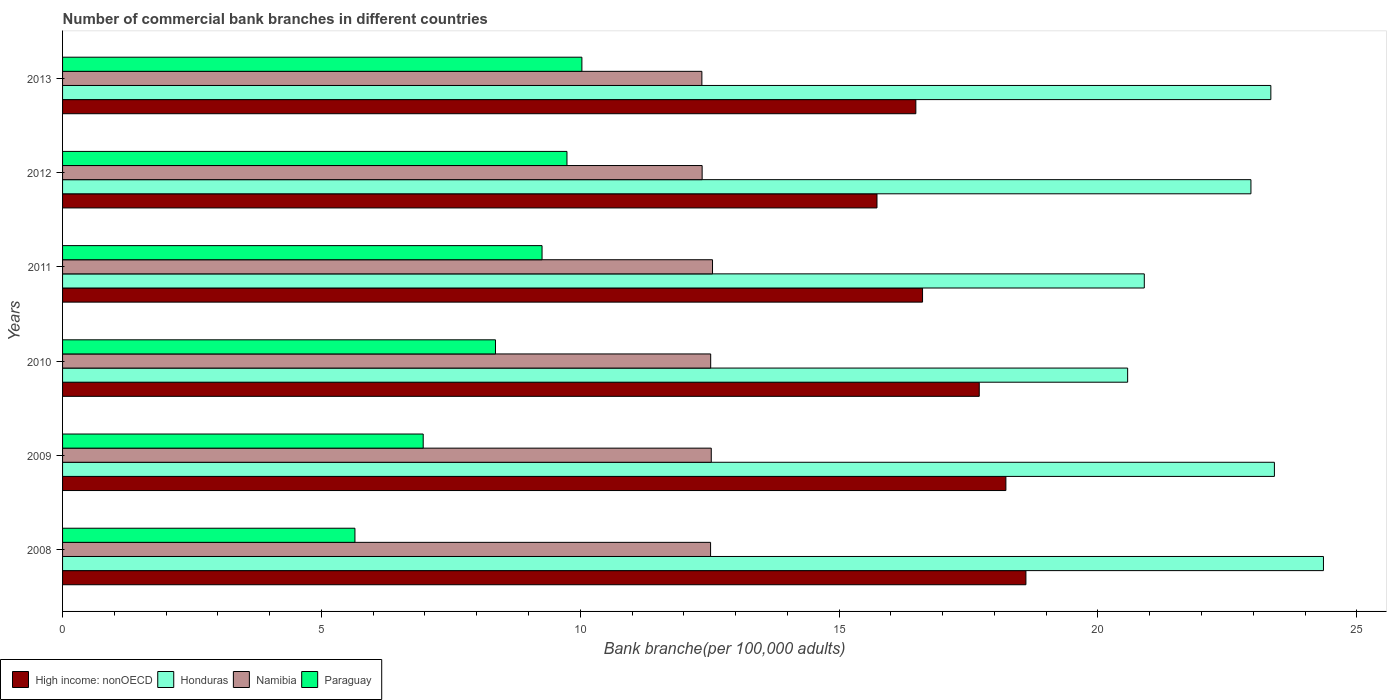Are the number of bars per tick equal to the number of legend labels?
Keep it short and to the point. Yes. How many bars are there on the 3rd tick from the bottom?
Your answer should be compact. 4. What is the label of the 5th group of bars from the top?
Keep it short and to the point. 2009. In how many cases, is the number of bars for a given year not equal to the number of legend labels?
Your answer should be compact. 0. What is the number of commercial bank branches in Namibia in 2013?
Ensure brevity in your answer.  12.35. Across all years, what is the maximum number of commercial bank branches in Namibia?
Keep it short and to the point. 12.55. Across all years, what is the minimum number of commercial bank branches in High income: nonOECD?
Provide a succinct answer. 15.73. In which year was the number of commercial bank branches in Honduras maximum?
Offer a terse response. 2008. What is the total number of commercial bank branches in Honduras in the graph?
Your response must be concise. 135.52. What is the difference between the number of commercial bank branches in High income: nonOECD in 2008 and that in 2011?
Offer a very short reply. 2. What is the difference between the number of commercial bank branches in Honduras in 2009 and the number of commercial bank branches in High income: nonOECD in 2012?
Ensure brevity in your answer.  7.68. What is the average number of commercial bank branches in High income: nonOECD per year?
Give a very brief answer. 17.23. In the year 2013, what is the difference between the number of commercial bank branches in Honduras and number of commercial bank branches in High income: nonOECD?
Offer a terse response. 6.86. In how many years, is the number of commercial bank branches in Namibia greater than 4 ?
Offer a terse response. 6. What is the ratio of the number of commercial bank branches in Paraguay in 2010 to that in 2011?
Provide a short and direct response. 0.9. What is the difference between the highest and the second highest number of commercial bank branches in High income: nonOECD?
Ensure brevity in your answer.  0.39. What is the difference between the highest and the lowest number of commercial bank branches in Honduras?
Ensure brevity in your answer.  3.78. In how many years, is the number of commercial bank branches in Honduras greater than the average number of commercial bank branches in Honduras taken over all years?
Provide a short and direct response. 4. What does the 2nd bar from the top in 2011 represents?
Give a very brief answer. Namibia. What does the 3rd bar from the bottom in 2011 represents?
Ensure brevity in your answer.  Namibia. How many bars are there?
Make the answer very short. 24. How many years are there in the graph?
Give a very brief answer. 6. What is the difference between two consecutive major ticks on the X-axis?
Provide a short and direct response. 5. Does the graph contain any zero values?
Offer a very short reply. No. What is the title of the graph?
Offer a terse response. Number of commercial bank branches in different countries. What is the label or title of the X-axis?
Keep it short and to the point. Bank branche(per 100,0 adults). What is the label or title of the Y-axis?
Give a very brief answer. Years. What is the Bank branche(per 100,000 adults) of High income: nonOECD in 2008?
Your answer should be compact. 18.61. What is the Bank branche(per 100,000 adults) in Honduras in 2008?
Provide a short and direct response. 24.36. What is the Bank branche(per 100,000 adults) of Namibia in 2008?
Your answer should be compact. 12.52. What is the Bank branche(per 100,000 adults) of Paraguay in 2008?
Your answer should be very brief. 5.65. What is the Bank branche(per 100,000 adults) in High income: nonOECD in 2009?
Offer a terse response. 18.22. What is the Bank branche(per 100,000 adults) in Honduras in 2009?
Your response must be concise. 23.41. What is the Bank branche(per 100,000 adults) in Namibia in 2009?
Make the answer very short. 12.53. What is the Bank branche(per 100,000 adults) in Paraguay in 2009?
Give a very brief answer. 6.97. What is the Bank branche(per 100,000 adults) in High income: nonOECD in 2010?
Give a very brief answer. 17.71. What is the Bank branche(per 100,000 adults) in Honduras in 2010?
Offer a very short reply. 20.57. What is the Bank branche(per 100,000 adults) of Namibia in 2010?
Give a very brief answer. 12.52. What is the Bank branche(per 100,000 adults) of Paraguay in 2010?
Give a very brief answer. 8.36. What is the Bank branche(per 100,000 adults) of High income: nonOECD in 2011?
Your response must be concise. 16.61. What is the Bank branche(per 100,000 adults) in Honduras in 2011?
Provide a short and direct response. 20.89. What is the Bank branche(per 100,000 adults) of Namibia in 2011?
Provide a short and direct response. 12.55. What is the Bank branche(per 100,000 adults) of Paraguay in 2011?
Ensure brevity in your answer.  9.26. What is the Bank branche(per 100,000 adults) of High income: nonOECD in 2012?
Offer a very short reply. 15.73. What is the Bank branche(per 100,000 adults) in Honduras in 2012?
Provide a short and direct response. 22.95. What is the Bank branche(per 100,000 adults) in Namibia in 2012?
Your answer should be compact. 12.35. What is the Bank branche(per 100,000 adults) in Paraguay in 2012?
Provide a succinct answer. 9.74. What is the Bank branche(per 100,000 adults) in High income: nonOECD in 2013?
Ensure brevity in your answer.  16.48. What is the Bank branche(per 100,000 adults) in Honduras in 2013?
Your response must be concise. 23.34. What is the Bank branche(per 100,000 adults) in Namibia in 2013?
Make the answer very short. 12.35. What is the Bank branche(per 100,000 adults) of Paraguay in 2013?
Keep it short and to the point. 10.03. Across all years, what is the maximum Bank branche(per 100,000 adults) of High income: nonOECD?
Your answer should be compact. 18.61. Across all years, what is the maximum Bank branche(per 100,000 adults) of Honduras?
Provide a short and direct response. 24.36. Across all years, what is the maximum Bank branche(per 100,000 adults) of Namibia?
Offer a terse response. 12.55. Across all years, what is the maximum Bank branche(per 100,000 adults) in Paraguay?
Offer a very short reply. 10.03. Across all years, what is the minimum Bank branche(per 100,000 adults) of High income: nonOECD?
Your answer should be compact. 15.73. Across all years, what is the minimum Bank branche(per 100,000 adults) in Honduras?
Provide a succinct answer. 20.57. Across all years, what is the minimum Bank branche(per 100,000 adults) of Namibia?
Your answer should be compact. 12.35. Across all years, what is the minimum Bank branche(per 100,000 adults) of Paraguay?
Your answer should be very brief. 5.65. What is the total Bank branche(per 100,000 adults) in High income: nonOECD in the graph?
Provide a short and direct response. 103.36. What is the total Bank branche(per 100,000 adults) in Honduras in the graph?
Provide a succinct answer. 135.52. What is the total Bank branche(per 100,000 adults) in Namibia in the graph?
Make the answer very short. 74.82. What is the total Bank branche(per 100,000 adults) of Paraguay in the graph?
Ensure brevity in your answer.  50.01. What is the difference between the Bank branche(per 100,000 adults) in High income: nonOECD in 2008 and that in 2009?
Make the answer very short. 0.39. What is the difference between the Bank branche(per 100,000 adults) of Honduras in 2008 and that in 2009?
Keep it short and to the point. 0.95. What is the difference between the Bank branche(per 100,000 adults) of Namibia in 2008 and that in 2009?
Give a very brief answer. -0.01. What is the difference between the Bank branche(per 100,000 adults) in Paraguay in 2008 and that in 2009?
Your answer should be very brief. -1.32. What is the difference between the Bank branche(per 100,000 adults) of High income: nonOECD in 2008 and that in 2010?
Provide a short and direct response. 0.9. What is the difference between the Bank branche(per 100,000 adults) of Honduras in 2008 and that in 2010?
Keep it short and to the point. 3.78. What is the difference between the Bank branche(per 100,000 adults) of Namibia in 2008 and that in 2010?
Provide a succinct answer. -0. What is the difference between the Bank branche(per 100,000 adults) in Paraguay in 2008 and that in 2010?
Your response must be concise. -2.71. What is the difference between the Bank branche(per 100,000 adults) in High income: nonOECD in 2008 and that in 2011?
Make the answer very short. 2. What is the difference between the Bank branche(per 100,000 adults) of Honduras in 2008 and that in 2011?
Provide a succinct answer. 3.46. What is the difference between the Bank branche(per 100,000 adults) in Namibia in 2008 and that in 2011?
Provide a succinct answer. -0.04. What is the difference between the Bank branche(per 100,000 adults) in Paraguay in 2008 and that in 2011?
Offer a terse response. -3.61. What is the difference between the Bank branche(per 100,000 adults) in High income: nonOECD in 2008 and that in 2012?
Keep it short and to the point. 2.88. What is the difference between the Bank branche(per 100,000 adults) of Honduras in 2008 and that in 2012?
Offer a very short reply. 1.4. What is the difference between the Bank branche(per 100,000 adults) in Namibia in 2008 and that in 2012?
Offer a terse response. 0.16. What is the difference between the Bank branche(per 100,000 adults) in Paraguay in 2008 and that in 2012?
Offer a very short reply. -4.1. What is the difference between the Bank branche(per 100,000 adults) of High income: nonOECD in 2008 and that in 2013?
Make the answer very short. 2.13. What is the difference between the Bank branche(per 100,000 adults) of Honduras in 2008 and that in 2013?
Make the answer very short. 1.02. What is the difference between the Bank branche(per 100,000 adults) of Namibia in 2008 and that in 2013?
Keep it short and to the point. 0.17. What is the difference between the Bank branche(per 100,000 adults) of Paraguay in 2008 and that in 2013?
Offer a very short reply. -4.38. What is the difference between the Bank branche(per 100,000 adults) of High income: nonOECD in 2009 and that in 2010?
Offer a terse response. 0.51. What is the difference between the Bank branche(per 100,000 adults) in Honduras in 2009 and that in 2010?
Make the answer very short. 2.83. What is the difference between the Bank branche(per 100,000 adults) in Namibia in 2009 and that in 2010?
Your answer should be very brief. 0.01. What is the difference between the Bank branche(per 100,000 adults) in Paraguay in 2009 and that in 2010?
Offer a terse response. -1.4. What is the difference between the Bank branche(per 100,000 adults) of High income: nonOECD in 2009 and that in 2011?
Provide a short and direct response. 1.61. What is the difference between the Bank branche(per 100,000 adults) of Honduras in 2009 and that in 2011?
Make the answer very short. 2.51. What is the difference between the Bank branche(per 100,000 adults) of Namibia in 2009 and that in 2011?
Provide a succinct answer. -0.02. What is the difference between the Bank branche(per 100,000 adults) in Paraguay in 2009 and that in 2011?
Ensure brevity in your answer.  -2.3. What is the difference between the Bank branche(per 100,000 adults) of High income: nonOECD in 2009 and that in 2012?
Your answer should be compact. 2.49. What is the difference between the Bank branche(per 100,000 adults) in Honduras in 2009 and that in 2012?
Your response must be concise. 0.45. What is the difference between the Bank branche(per 100,000 adults) in Namibia in 2009 and that in 2012?
Offer a terse response. 0.18. What is the difference between the Bank branche(per 100,000 adults) in Paraguay in 2009 and that in 2012?
Offer a very short reply. -2.78. What is the difference between the Bank branche(per 100,000 adults) in High income: nonOECD in 2009 and that in 2013?
Your answer should be compact. 1.74. What is the difference between the Bank branche(per 100,000 adults) in Honduras in 2009 and that in 2013?
Give a very brief answer. 0.07. What is the difference between the Bank branche(per 100,000 adults) of Namibia in 2009 and that in 2013?
Your response must be concise. 0.18. What is the difference between the Bank branche(per 100,000 adults) of Paraguay in 2009 and that in 2013?
Offer a terse response. -3.06. What is the difference between the Bank branche(per 100,000 adults) in High income: nonOECD in 2010 and that in 2011?
Make the answer very short. 1.1. What is the difference between the Bank branche(per 100,000 adults) in Honduras in 2010 and that in 2011?
Ensure brevity in your answer.  -0.32. What is the difference between the Bank branche(per 100,000 adults) in Namibia in 2010 and that in 2011?
Provide a succinct answer. -0.04. What is the difference between the Bank branche(per 100,000 adults) of Paraguay in 2010 and that in 2011?
Offer a very short reply. -0.9. What is the difference between the Bank branche(per 100,000 adults) of High income: nonOECD in 2010 and that in 2012?
Offer a terse response. 1.98. What is the difference between the Bank branche(per 100,000 adults) in Honduras in 2010 and that in 2012?
Ensure brevity in your answer.  -2.38. What is the difference between the Bank branche(per 100,000 adults) of Namibia in 2010 and that in 2012?
Your response must be concise. 0.17. What is the difference between the Bank branche(per 100,000 adults) in Paraguay in 2010 and that in 2012?
Make the answer very short. -1.38. What is the difference between the Bank branche(per 100,000 adults) in High income: nonOECD in 2010 and that in 2013?
Ensure brevity in your answer.  1.22. What is the difference between the Bank branche(per 100,000 adults) of Honduras in 2010 and that in 2013?
Give a very brief answer. -2.77. What is the difference between the Bank branche(per 100,000 adults) in Namibia in 2010 and that in 2013?
Your response must be concise. 0.17. What is the difference between the Bank branche(per 100,000 adults) in Paraguay in 2010 and that in 2013?
Ensure brevity in your answer.  -1.67. What is the difference between the Bank branche(per 100,000 adults) of High income: nonOECD in 2011 and that in 2012?
Your answer should be compact. 0.88. What is the difference between the Bank branche(per 100,000 adults) in Honduras in 2011 and that in 2012?
Your response must be concise. -2.06. What is the difference between the Bank branche(per 100,000 adults) in Namibia in 2011 and that in 2012?
Offer a very short reply. 0.2. What is the difference between the Bank branche(per 100,000 adults) of Paraguay in 2011 and that in 2012?
Make the answer very short. -0.48. What is the difference between the Bank branche(per 100,000 adults) of High income: nonOECD in 2011 and that in 2013?
Give a very brief answer. 0.13. What is the difference between the Bank branche(per 100,000 adults) of Honduras in 2011 and that in 2013?
Your response must be concise. -2.44. What is the difference between the Bank branche(per 100,000 adults) of Namibia in 2011 and that in 2013?
Your response must be concise. 0.21. What is the difference between the Bank branche(per 100,000 adults) of Paraguay in 2011 and that in 2013?
Your answer should be very brief. -0.77. What is the difference between the Bank branche(per 100,000 adults) in High income: nonOECD in 2012 and that in 2013?
Offer a terse response. -0.75. What is the difference between the Bank branche(per 100,000 adults) in Honduras in 2012 and that in 2013?
Give a very brief answer. -0.38. What is the difference between the Bank branche(per 100,000 adults) of Namibia in 2012 and that in 2013?
Keep it short and to the point. 0. What is the difference between the Bank branche(per 100,000 adults) of Paraguay in 2012 and that in 2013?
Offer a terse response. -0.29. What is the difference between the Bank branche(per 100,000 adults) in High income: nonOECD in 2008 and the Bank branche(per 100,000 adults) in Honduras in 2009?
Offer a very short reply. -4.8. What is the difference between the Bank branche(per 100,000 adults) in High income: nonOECD in 2008 and the Bank branche(per 100,000 adults) in Namibia in 2009?
Provide a succinct answer. 6.08. What is the difference between the Bank branche(per 100,000 adults) of High income: nonOECD in 2008 and the Bank branche(per 100,000 adults) of Paraguay in 2009?
Your answer should be very brief. 11.64. What is the difference between the Bank branche(per 100,000 adults) of Honduras in 2008 and the Bank branche(per 100,000 adults) of Namibia in 2009?
Your answer should be compact. 11.82. What is the difference between the Bank branche(per 100,000 adults) of Honduras in 2008 and the Bank branche(per 100,000 adults) of Paraguay in 2009?
Your answer should be very brief. 17.39. What is the difference between the Bank branche(per 100,000 adults) of Namibia in 2008 and the Bank branche(per 100,000 adults) of Paraguay in 2009?
Provide a succinct answer. 5.55. What is the difference between the Bank branche(per 100,000 adults) in High income: nonOECD in 2008 and the Bank branche(per 100,000 adults) in Honduras in 2010?
Provide a succinct answer. -1.97. What is the difference between the Bank branche(per 100,000 adults) in High income: nonOECD in 2008 and the Bank branche(per 100,000 adults) in Namibia in 2010?
Your answer should be very brief. 6.09. What is the difference between the Bank branche(per 100,000 adults) in High income: nonOECD in 2008 and the Bank branche(per 100,000 adults) in Paraguay in 2010?
Offer a terse response. 10.25. What is the difference between the Bank branche(per 100,000 adults) of Honduras in 2008 and the Bank branche(per 100,000 adults) of Namibia in 2010?
Provide a succinct answer. 11.84. What is the difference between the Bank branche(per 100,000 adults) in Honduras in 2008 and the Bank branche(per 100,000 adults) in Paraguay in 2010?
Give a very brief answer. 15.99. What is the difference between the Bank branche(per 100,000 adults) in Namibia in 2008 and the Bank branche(per 100,000 adults) in Paraguay in 2010?
Give a very brief answer. 4.15. What is the difference between the Bank branche(per 100,000 adults) of High income: nonOECD in 2008 and the Bank branche(per 100,000 adults) of Honduras in 2011?
Your answer should be very brief. -2.29. What is the difference between the Bank branche(per 100,000 adults) in High income: nonOECD in 2008 and the Bank branche(per 100,000 adults) in Namibia in 2011?
Make the answer very short. 6.05. What is the difference between the Bank branche(per 100,000 adults) of High income: nonOECD in 2008 and the Bank branche(per 100,000 adults) of Paraguay in 2011?
Make the answer very short. 9.35. What is the difference between the Bank branche(per 100,000 adults) of Honduras in 2008 and the Bank branche(per 100,000 adults) of Namibia in 2011?
Provide a succinct answer. 11.8. What is the difference between the Bank branche(per 100,000 adults) of Honduras in 2008 and the Bank branche(per 100,000 adults) of Paraguay in 2011?
Offer a terse response. 15.09. What is the difference between the Bank branche(per 100,000 adults) of Namibia in 2008 and the Bank branche(per 100,000 adults) of Paraguay in 2011?
Offer a terse response. 3.26. What is the difference between the Bank branche(per 100,000 adults) of High income: nonOECD in 2008 and the Bank branche(per 100,000 adults) of Honduras in 2012?
Offer a very short reply. -4.35. What is the difference between the Bank branche(per 100,000 adults) in High income: nonOECD in 2008 and the Bank branche(per 100,000 adults) in Namibia in 2012?
Your answer should be compact. 6.25. What is the difference between the Bank branche(per 100,000 adults) in High income: nonOECD in 2008 and the Bank branche(per 100,000 adults) in Paraguay in 2012?
Give a very brief answer. 8.87. What is the difference between the Bank branche(per 100,000 adults) of Honduras in 2008 and the Bank branche(per 100,000 adults) of Namibia in 2012?
Make the answer very short. 12. What is the difference between the Bank branche(per 100,000 adults) of Honduras in 2008 and the Bank branche(per 100,000 adults) of Paraguay in 2012?
Make the answer very short. 14.61. What is the difference between the Bank branche(per 100,000 adults) of Namibia in 2008 and the Bank branche(per 100,000 adults) of Paraguay in 2012?
Your answer should be very brief. 2.77. What is the difference between the Bank branche(per 100,000 adults) in High income: nonOECD in 2008 and the Bank branche(per 100,000 adults) in Honduras in 2013?
Keep it short and to the point. -4.73. What is the difference between the Bank branche(per 100,000 adults) of High income: nonOECD in 2008 and the Bank branche(per 100,000 adults) of Namibia in 2013?
Make the answer very short. 6.26. What is the difference between the Bank branche(per 100,000 adults) of High income: nonOECD in 2008 and the Bank branche(per 100,000 adults) of Paraguay in 2013?
Offer a terse response. 8.58. What is the difference between the Bank branche(per 100,000 adults) of Honduras in 2008 and the Bank branche(per 100,000 adults) of Namibia in 2013?
Provide a short and direct response. 12.01. What is the difference between the Bank branche(per 100,000 adults) in Honduras in 2008 and the Bank branche(per 100,000 adults) in Paraguay in 2013?
Your answer should be compact. 14.32. What is the difference between the Bank branche(per 100,000 adults) in Namibia in 2008 and the Bank branche(per 100,000 adults) in Paraguay in 2013?
Offer a very short reply. 2.49. What is the difference between the Bank branche(per 100,000 adults) of High income: nonOECD in 2009 and the Bank branche(per 100,000 adults) of Honduras in 2010?
Provide a succinct answer. -2.35. What is the difference between the Bank branche(per 100,000 adults) of High income: nonOECD in 2009 and the Bank branche(per 100,000 adults) of Namibia in 2010?
Offer a terse response. 5.7. What is the difference between the Bank branche(per 100,000 adults) of High income: nonOECD in 2009 and the Bank branche(per 100,000 adults) of Paraguay in 2010?
Your answer should be compact. 9.86. What is the difference between the Bank branche(per 100,000 adults) in Honduras in 2009 and the Bank branche(per 100,000 adults) in Namibia in 2010?
Ensure brevity in your answer.  10.89. What is the difference between the Bank branche(per 100,000 adults) in Honduras in 2009 and the Bank branche(per 100,000 adults) in Paraguay in 2010?
Ensure brevity in your answer.  15.05. What is the difference between the Bank branche(per 100,000 adults) in Namibia in 2009 and the Bank branche(per 100,000 adults) in Paraguay in 2010?
Offer a terse response. 4.17. What is the difference between the Bank branche(per 100,000 adults) of High income: nonOECD in 2009 and the Bank branche(per 100,000 adults) of Honduras in 2011?
Your response must be concise. -2.67. What is the difference between the Bank branche(per 100,000 adults) in High income: nonOECD in 2009 and the Bank branche(per 100,000 adults) in Namibia in 2011?
Keep it short and to the point. 5.67. What is the difference between the Bank branche(per 100,000 adults) of High income: nonOECD in 2009 and the Bank branche(per 100,000 adults) of Paraguay in 2011?
Provide a succinct answer. 8.96. What is the difference between the Bank branche(per 100,000 adults) of Honduras in 2009 and the Bank branche(per 100,000 adults) of Namibia in 2011?
Provide a succinct answer. 10.85. What is the difference between the Bank branche(per 100,000 adults) of Honduras in 2009 and the Bank branche(per 100,000 adults) of Paraguay in 2011?
Offer a terse response. 14.15. What is the difference between the Bank branche(per 100,000 adults) of Namibia in 2009 and the Bank branche(per 100,000 adults) of Paraguay in 2011?
Your answer should be very brief. 3.27. What is the difference between the Bank branche(per 100,000 adults) of High income: nonOECD in 2009 and the Bank branche(per 100,000 adults) of Honduras in 2012?
Offer a terse response. -4.73. What is the difference between the Bank branche(per 100,000 adults) in High income: nonOECD in 2009 and the Bank branche(per 100,000 adults) in Namibia in 2012?
Make the answer very short. 5.87. What is the difference between the Bank branche(per 100,000 adults) in High income: nonOECD in 2009 and the Bank branche(per 100,000 adults) in Paraguay in 2012?
Offer a terse response. 8.48. What is the difference between the Bank branche(per 100,000 adults) in Honduras in 2009 and the Bank branche(per 100,000 adults) in Namibia in 2012?
Provide a short and direct response. 11.05. What is the difference between the Bank branche(per 100,000 adults) in Honduras in 2009 and the Bank branche(per 100,000 adults) in Paraguay in 2012?
Make the answer very short. 13.66. What is the difference between the Bank branche(per 100,000 adults) of Namibia in 2009 and the Bank branche(per 100,000 adults) of Paraguay in 2012?
Give a very brief answer. 2.79. What is the difference between the Bank branche(per 100,000 adults) in High income: nonOECD in 2009 and the Bank branche(per 100,000 adults) in Honduras in 2013?
Give a very brief answer. -5.12. What is the difference between the Bank branche(per 100,000 adults) in High income: nonOECD in 2009 and the Bank branche(per 100,000 adults) in Namibia in 2013?
Make the answer very short. 5.87. What is the difference between the Bank branche(per 100,000 adults) in High income: nonOECD in 2009 and the Bank branche(per 100,000 adults) in Paraguay in 2013?
Keep it short and to the point. 8.19. What is the difference between the Bank branche(per 100,000 adults) in Honduras in 2009 and the Bank branche(per 100,000 adults) in Namibia in 2013?
Your response must be concise. 11.06. What is the difference between the Bank branche(per 100,000 adults) in Honduras in 2009 and the Bank branche(per 100,000 adults) in Paraguay in 2013?
Your response must be concise. 13.38. What is the difference between the Bank branche(per 100,000 adults) in Namibia in 2009 and the Bank branche(per 100,000 adults) in Paraguay in 2013?
Ensure brevity in your answer.  2.5. What is the difference between the Bank branche(per 100,000 adults) of High income: nonOECD in 2010 and the Bank branche(per 100,000 adults) of Honduras in 2011?
Your answer should be compact. -3.19. What is the difference between the Bank branche(per 100,000 adults) of High income: nonOECD in 2010 and the Bank branche(per 100,000 adults) of Namibia in 2011?
Give a very brief answer. 5.15. What is the difference between the Bank branche(per 100,000 adults) in High income: nonOECD in 2010 and the Bank branche(per 100,000 adults) in Paraguay in 2011?
Provide a short and direct response. 8.44. What is the difference between the Bank branche(per 100,000 adults) in Honduras in 2010 and the Bank branche(per 100,000 adults) in Namibia in 2011?
Offer a terse response. 8.02. What is the difference between the Bank branche(per 100,000 adults) of Honduras in 2010 and the Bank branche(per 100,000 adults) of Paraguay in 2011?
Make the answer very short. 11.31. What is the difference between the Bank branche(per 100,000 adults) of Namibia in 2010 and the Bank branche(per 100,000 adults) of Paraguay in 2011?
Provide a succinct answer. 3.26. What is the difference between the Bank branche(per 100,000 adults) in High income: nonOECD in 2010 and the Bank branche(per 100,000 adults) in Honduras in 2012?
Keep it short and to the point. -5.25. What is the difference between the Bank branche(per 100,000 adults) of High income: nonOECD in 2010 and the Bank branche(per 100,000 adults) of Namibia in 2012?
Provide a short and direct response. 5.35. What is the difference between the Bank branche(per 100,000 adults) in High income: nonOECD in 2010 and the Bank branche(per 100,000 adults) in Paraguay in 2012?
Provide a succinct answer. 7.96. What is the difference between the Bank branche(per 100,000 adults) in Honduras in 2010 and the Bank branche(per 100,000 adults) in Namibia in 2012?
Keep it short and to the point. 8.22. What is the difference between the Bank branche(per 100,000 adults) in Honduras in 2010 and the Bank branche(per 100,000 adults) in Paraguay in 2012?
Provide a short and direct response. 10.83. What is the difference between the Bank branche(per 100,000 adults) in Namibia in 2010 and the Bank branche(per 100,000 adults) in Paraguay in 2012?
Make the answer very short. 2.78. What is the difference between the Bank branche(per 100,000 adults) in High income: nonOECD in 2010 and the Bank branche(per 100,000 adults) in Honduras in 2013?
Keep it short and to the point. -5.63. What is the difference between the Bank branche(per 100,000 adults) in High income: nonOECD in 2010 and the Bank branche(per 100,000 adults) in Namibia in 2013?
Provide a succinct answer. 5.36. What is the difference between the Bank branche(per 100,000 adults) of High income: nonOECD in 2010 and the Bank branche(per 100,000 adults) of Paraguay in 2013?
Make the answer very short. 7.68. What is the difference between the Bank branche(per 100,000 adults) of Honduras in 2010 and the Bank branche(per 100,000 adults) of Namibia in 2013?
Offer a very short reply. 8.22. What is the difference between the Bank branche(per 100,000 adults) in Honduras in 2010 and the Bank branche(per 100,000 adults) in Paraguay in 2013?
Keep it short and to the point. 10.54. What is the difference between the Bank branche(per 100,000 adults) of Namibia in 2010 and the Bank branche(per 100,000 adults) of Paraguay in 2013?
Your answer should be compact. 2.49. What is the difference between the Bank branche(per 100,000 adults) in High income: nonOECD in 2011 and the Bank branche(per 100,000 adults) in Honduras in 2012?
Provide a short and direct response. -6.34. What is the difference between the Bank branche(per 100,000 adults) of High income: nonOECD in 2011 and the Bank branche(per 100,000 adults) of Namibia in 2012?
Your response must be concise. 4.26. What is the difference between the Bank branche(per 100,000 adults) in High income: nonOECD in 2011 and the Bank branche(per 100,000 adults) in Paraguay in 2012?
Your answer should be compact. 6.87. What is the difference between the Bank branche(per 100,000 adults) of Honduras in 2011 and the Bank branche(per 100,000 adults) of Namibia in 2012?
Offer a very short reply. 8.54. What is the difference between the Bank branche(per 100,000 adults) of Honduras in 2011 and the Bank branche(per 100,000 adults) of Paraguay in 2012?
Make the answer very short. 11.15. What is the difference between the Bank branche(per 100,000 adults) of Namibia in 2011 and the Bank branche(per 100,000 adults) of Paraguay in 2012?
Provide a succinct answer. 2.81. What is the difference between the Bank branche(per 100,000 adults) of High income: nonOECD in 2011 and the Bank branche(per 100,000 adults) of Honduras in 2013?
Provide a short and direct response. -6.73. What is the difference between the Bank branche(per 100,000 adults) of High income: nonOECD in 2011 and the Bank branche(per 100,000 adults) of Namibia in 2013?
Make the answer very short. 4.26. What is the difference between the Bank branche(per 100,000 adults) of High income: nonOECD in 2011 and the Bank branche(per 100,000 adults) of Paraguay in 2013?
Your answer should be very brief. 6.58. What is the difference between the Bank branche(per 100,000 adults) in Honduras in 2011 and the Bank branche(per 100,000 adults) in Namibia in 2013?
Your answer should be very brief. 8.55. What is the difference between the Bank branche(per 100,000 adults) of Honduras in 2011 and the Bank branche(per 100,000 adults) of Paraguay in 2013?
Your answer should be very brief. 10.86. What is the difference between the Bank branche(per 100,000 adults) of Namibia in 2011 and the Bank branche(per 100,000 adults) of Paraguay in 2013?
Offer a very short reply. 2.52. What is the difference between the Bank branche(per 100,000 adults) in High income: nonOECD in 2012 and the Bank branche(per 100,000 adults) in Honduras in 2013?
Your response must be concise. -7.61. What is the difference between the Bank branche(per 100,000 adults) of High income: nonOECD in 2012 and the Bank branche(per 100,000 adults) of Namibia in 2013?
Your answer should be compact. 3.38. What is the difference between the Bank branche(per 100,000 adults) of High income: nonOECD in 2012 and the Bank branche(per 100,000 adults) of Paraguay in 2013?
Give a very brief answer. 5.7. What is the difference between the Bank branche(per 100,000 adults) in Honduras in 2012 and the Bank branche(per 100,000 adults) in Namibia in 2013?
Your response must be concise. 10.61. What is the difference between the Bank branche(per 100,000 adults) of Honduras in 2012 and the Bank branche(per 100,000 adults) of Paraguay in 2013?
Your response must be concise. 12.92. What is the difference between the Bank branche(per 100,000 adults) in Namibia in 2012 and the Bank branche(per 100,000 adults) in Paraguay in 2013?
Give a very brief answer. 2.32. What is the average Bank branche(per 100,000 adults) of High income: nonOECD per year?
Provide a short and direct response. 17.23. What is the average Bank branche(per 100,000 adults) of Honduras per year?
Keep it short and to the point. 22.59. What is the average Bank branche(per 100,000 adults) in Namibia per year?
Your answer should be very brief. 12.47. What is the average Bank branche(per 100,000 adults) of Paraguay per year?
Keep it short and to the point. 8.34. In the year 2008, what is the difference between the Bank branche(per 100,000 adults) in High income: nonOECD and Bank branche(per 100,000 adults) in Honduras?
Provide a short and direct response. -5.75. In the year 2008, what is the difference between the Bank branche(per 100,000 adults) of High income: nonOECD and Bank branche(per 100,000 adults) of Namibia?
Your answer should be very brief. 6.09. In the year 2008, what is the difference between the Bank branche(per 100,000 adults) of High income: nonOECD and Bank branche(per 100,000 adults) of Paraguay?
Give a very brief answer. 12.96. In the year 2008, what is the difference between the Bank branche(per 100,000 adults) of Honduras and Bank branche(per 100,000 adults) of Namibia?
Keep it short and to the point. 11.84. In the year 2008, what is the difference between the Bank branche(per 100,000 adults) of Honduras and Bank branche(per 100,000 adults) of Paraguay?
Make the answer very short. 18.71. In the year 2008, what is the difference between the Bank branche(per 100,000 adults) in Namibia and Bank branche(per 100,000 adults) in Paraguay?
Make the answer very short. 6.87. In the year 2009, what is the difference between the Bank branche(per 100,000 adults) in High income: nonOECD and Bank branche(per 100,000 adults) in Honduras?
Keep it short and to the point. -5.19. In the year 2009, what is the difference between the Bank branche(per 100,000 adults) in High income: nonOECD and Bank branche(per 100,000 adults) in Namibia?
Offer a terse response. 5.69. In the year 2009, what is the difference between the Bank branche(per 100,000 adults) in High income: nonOECD and Bank branche(per 100,000 adults) in Paraguay?
Your answer should be very brief. 11.26. In the year 2009, what is the difference between the Bank branche(per 100,000 adults) in Honduras and Bank branche(per 100,000 adults) in Namibia?
Offer a terse response. 10.88. In the year 2009, what is the difference between the Bank branche(per 100,000 adults) of Honduras and Bank branche(per 100,000 adults) of Paraguay?
Ensure brevity in your answer.  16.44. In the year 2009, what is the difference between the Bank branche(per 100,000 adults) of Namibia and Bank branche(per 100,000 adults) of Paraguay?
Provide a succinct answer. 5.56. In the year 2010, what is the difference between the Bank branche(per 100,000 adults) of High income: nonOECD and Bank branche(per 100,000 adults) of Honduras?
Provide a short and direct response. -2.87. In the year 2010, what is the difference between the Bank branche(per 100,000 adults) in High income: nonOECD and Bank branche(per 100,000 adults) in Namibia?
Provide a short and direct response. 5.19. In the year 2010, what is the difference between the Bank branche(per 100,000 adults) in High income: nonOECD and Bank branche(per 100,000 adults) in Paraguay?
Provide a succinct answer. 9.34. In the year 2010, what is the difference between the Bank branche(per 100,000 adults) of Honduras and Bank branche(per 100,000 adults) of Namibia?
Keep it short and to the point. 8.05. In the year 2010, what is the difference between the Bank branche(per 100,000 adults) of Honduras and Bank branche(per 100,000 adults) of Paraguay?
Keep it short and to the point. 12.21. In the year 2010, what is the difference between the Bank branche(per 100,000 adults) in Namibia and Bank branche(per 100,000 adults) in Paraguay?
Your answer should be very brief. 4.16. In the year 2011, what is the difference between the Bank branche(per 100,000 adults) of High income: nonOECD and Bank branche(per 100,000 adults) of Honduras?
Offer a terse response. -4.28. In the year 2011, what is the difference between the Bank branche(per 100,000 adults) of High income: nonOECD and Bank branche(per 100,000 adults) of Namibia?
Offer a terse response. 4.06. In the year 2011, what is the difference between the Bank branche(per 100,000 adults) in High income: nonOECD and Bank branche(per 100,000 adults) in Paraguay?
Your answer should be compact. 7.35. In the year 2011, what is the difference between the Bank branche(per 100,000 adults) of Honduras and Bank branche(per 100,000 adults) of Namibia?
Keep it short and to the point. 8.34. In the year 2011, what is the difference between the Bank branche(per 100,000 adults) of Honduras and Bank branche(per 100,000 adults) of Paraguay?
Offer a very short reply. 11.63. In the year 2011, what is the difference between the Bank branche(per 100,000 adults) in Namibia and Bank branche(per 100,000 adults) in Paraguay?
Offer a terse response. 3.29. In the year 2012, what is the difference between the Bank branche(per 100,000 adults) of High income: nonOECD and Bank branche(per 100,000 adults) of Honduras?
Offer a very short reply. -7.22. In the year 2012, what is the difference between the Bank branche(per 100,000 adults) in High income: nonOECD and Bank branche(per 100,000 adults) in Namibia?
Give a very brief answer. 3.38. In the year 2012, what is the difference between the Bank branche(per 100,000 adults) in High income: nonOECD and Bank branche(per 100,000 adults) in Paraguay?
Give a very brief answer. 5.99. In the year 2012, what is the difference between the Bank branche(per 100,000 adults) of Honduras and Bank branche(per 100,000 adults) of Namibia?
Provide a succinct answer. 10.6. In the year 2012, what is the difference between the Bank branche(per 100,000 adults) of Honduras and Bank branche(per 100,000 adults) of Paraguay?
Your response must be concise. 13.21. In the year 2012, what is the difference between the Bank branche(per 100,000 adults) in Namibia and Bank branche(per 100,000 adults) in Paraguay?
Keep it short and to the point. 2.61. In the year 2013, what is the difference between the Bank branche(per 100,000 adults) in High income: nonOECD and Bank branche(per 100,000 adults) in Honduras?
Your response must be concise. -6.86. In the year 2013, what is the difference between the Bank branche(per 100,000 adults) of High income: nonOECD and Bank branche(per 100,000 adults) of Namibia?
Offer a terse response. 4.13. In the year 2013, what is the difference between the Bank branche(per 100,000 adults) of High income: nonOECD and Bank branche(per 100,000 adults) of Paraguay?
Offer a terse response. 6.45. In the year 2013, what is the difference between the Bank branche(per 100,000 adults) in Honduras and Bank branche(per 100,000 adults) in Namibia?
Give a very brief answer. 10.99. In the year 2013, what is the difference between the Bank branche(per 100,000 adults) of Honduras and Bank branche(per 100,000 adults) of Paraguay?
Provide a short and direct response. 13.31. In the year 2013, what is the difference between the Bank branche(per 100,000 adults) in Namibia and Bank branche(per 100,000 adults) in Paraguay?
Provide a succinct answer. 2.32. What is the ratio of the Bank branche(per 100,000 adults) in High income: nonOECD in 2008 to that in 2009?
Offer a terse response. 1.02. What is the ratio of the Bank branche(per 100,000 adults) in Honduras in 2008 to that in 2009?
Ensure brevity in your answer.  1.04. What is the ratio of the Bank branche(per 100,000 adults) in Namibia in 2008 to that in 2009?
Your answer should be very brief. 1. What is the ratio of the Bank branche(per 100,000 adults) of Paraguay in 2008 to that in 2009?
Your answer should be compact. 0.81. What is the ratio of the Bank branche(per 100,000 adults) in High income: nonOECD in 2008 to that in 2010?
Your answer should be compact. 1.05. What is the ratio of the Bank branche(per 100,000 adults) in Honduras in 2008 to that in 2010?
Provide a short and direct response. 1.18. What is the ratio of the Bank branche(per 100,000 adults) in Paraguay in 2008 to that in 2010?
Provide a succinct answer. 0.68. What is the ratio of the Bank branche(per 100,000 adults) of High income: nonOECD in 2008 to that in 2011?
Your answer should be compact. 1.12. What is the ratio of the Bank branche(per 100,000 adults) of Honduras in 2008 to that in 2011?
Provide a short and direct response. 1.17. What is the ratio of the Bank branche(per 100,000 adults) in Paraguay in 2008 to that in 2011?
Your answer should be compact. 0.61. What is the ratio of the Bank branche(per 100,000 adults) of High income: nonOECD in 2008 to that in 2012?
Offer a terse response. 1.18. What is the ratio of the Bank branche(per 100,000 adults) in Honduras in 2008 to that in 2012?
Keep it short and to the point. 1.06. What is the ratio of the Bank branche(per 100,000 adults) in Namibia in 2008 to that in 2012?
Offer a very short reply. 1.01. What is the ratio of the Bank branche(per 100,000 adults) of Paraguay in 2008 to that in 2012?
Offer a very short reply. 0.58. What is the ratio of the Bank branche(per 100,000 adults) in High income: nonOECD in 2008 to that in 2013?
Ensure brevity in your answer.  1.13. What is the ratio of the Bank branche(per 100,000 adults) of Honduras in 2008 to that in 2013?
Your response must be concise. 1.04. What is the ratio of the Bank branche(per 100,000 adults) in Namibia in 2008 to that in 2013?
Provide a short and direct response. 1.01. What is the ratio of the Bank branche(per 100,000 adults) of Paraguay in 2008 to that in 2013?
Your answer should be compact. 0.56. What is the ratio of the Bank branche(per 100,000 adults) in High income: nonOECD in 2009 to that in 2010?
Keep it short and to the point. 1.03. What is the ratio of the Bank branche(per 100,000 adults) of Honduras in 2009 to that in 2010?
Provide a succinct answer. 1.14. What is the ratio of the Bank branche(per 100,000 adults) of Paraguay in 2009 to that in 2010?
Offer a very short reply. 0.83. What is the ratio of the Bank branche(per 100,000 adults) in High income: nonOECD in 2009 to that in 2011?
Keep it short and to the point. 1.1. What is the ratio of the Bank branche(per 100,000 adults) in Honduras in 2009 to that in 2011?
Offer a terse response. 1.12. What is the ratio of the Bank branche(per 100,000 adults) in Namibia in 2009 to that in 2011?
Your response must be concise. 1. What is the ratio of the Bank branche(per 100,000 adults) in Paraguay in 2009 to that in 2011?
Offer a very short reply. 0.75. What is the ratio of the Bank branche(per 100,000 adults) of High income: nonOECD in 2009 to that in 2012?
Keep it short and to the point. 1.16. What is the ratio of the Bank branche(per 100,000 adults) in Honduras in 2009 to that in 2012?
Your answer should be very brief. 1.02. What is the ratio of the Bank branche(per 100,000 adults) in Namibia in 2009 to that in 2012?
Provide a succinct answer. 1.01. What is the ratio of the Bank branche(per 100,000 adults) of Paraguay in 2009 to that in 2012?
Make the answer very short. 0.71. What is the ratio of the Bank branche(per 100,000 adults) of High income: nonOECD in 2009 to that in 2013?
Provide a short and direct response. 1.11. What is the ratio of the Bank branche(per 100,000 adults) of Honduras in 2009 to that in 2013?
Offer a very short reply. 1. What is the ratio of the Bank branche(per 100,000 adults) of Namibia in 2009 to that in 2013?
Keep it short and to the point. 1.01. What is the ratio of the Bank branche(per 100,000 adults) in Paraguay in 2009 to that in 2013?
Keep it short and to the point. 0.69. What is the ratio of the Bank branche(per 100,000 adults) in High income: nonOECD in 2010 to that in 2011?
Ensure brevity in your answer.  1.07. What is the ratio of the Bank branche(per 100,000 adults) of Honduras in 2010 to that in 2011?
Offer a terse response. 0.98. What is the ratio of the Bank branche(per 100,000 adults) of Namibia in 2010 to that in 2011?
Your answer should be very brief. 1. What is the ratio of the Bank branche(per 100,000 adults) in Paraguay in 2010 to that in 2011?
Your answer should be compact. 0.9. What is the ratio of the Bank branche(per 100,000 adults) of High income: nonOECD in 2010 to that in 2012?
Keep it short and to the point. 1.13. What is the ratio of the Bank branche(per 100,000 adults) in Honduras in 2010 to that in 2012?
Offer a terse response. 0.9. What is the ratio of the Bank branche(per 100,000 adults) in Namibia in 2010 to that in 2012?
Your answer should be very brief. 1.01. What is the ratio of the Bank branche(per 100,000 adults) of Paraguay in 2010 to that in 2012?
Your answer should be very brief. 0.86. What is the ratio of the Bank branche(per 100,000 adults) in High income: nonOECD in 2010 to that in 2013?
Offer a very short reply. 1.07. What is the ratio of the Bank branche(per 100,000 adults) in Honduras in 2010 to that in 2013?
Offer a very short reply. 0.88. What is the ratio of the Bank branche(per 100,000 adults) in Namibia in 2010 to that in 2013?
Keep it short and to the point. 1.01. What is the ratio of the Bank branche(per 100,000 adults) in Paraguay in 2010 to that in 2013?
Provide a short and direct response. 0.83. What is the ratio of the Bank branche(per 100,000 adults) in High income: nonOECD in 2011 to that in 2012?
Your response must be concise. 1.06. What is the ratio of the Bank branche(per 100,000 adults) in Honduras in 2011 to that in 2012?
Offer a very short reply. 0.91. What is the ratio of the Bank branche(per 100,000 adults) in Namibia in 2011 to that in 2012?
Provide a succinct answer. 1.02. What is the ratio of the Bank branche(per 100,000 adults) of Paraguay in 2011 to that in 2012?
Keep it short and to the point. 0.95. What is the ratio of the Bank branche(per 100,000 adults) in High income: nonOECD in 2011 to that in 2013?
Offer a terse response. 1.01. What is the ratio of the Bank branche(per 100,000 adults) of Honduras in 2011 to that in 2013?
Ensure brevity in your answer.  0.9. What is the ratio of the Bank branche(per 100,000 adults) in Namibia in 2011 to that in 2013?
Your answer should be compact. 1.02. What is the ratio of the Bank branche(per 100,000 adults) of Paraguay in 2011 to that in 2013?
Your response must be concise. 0.92. What is the ratio of the Bank branche(per 100,000 adults) of High income: nonOECD in 2012 to that in 2013?
Offer a terse response. 0.95. What is the ratio of the Bank branche(per 100,000 adults) of Honduras in 2012 to that in 2013?
Provide a short and direct response. 0.98. What is the ratio of the Bank branche(per 100,000 adults) of Namibia in 2012 to that in 2013?
Make the answer very short. 1. What is the ratio of the Bank branche(per 100,000 adults) in Paraguay in 2012 to that in 2013?
Offer a terse response. 0.97. What is the difference between the highest and the second highest Bank branche(per 100,000 adults) of High income: nonOECD?
Keep it short and to the point. 0.39. What is the difference between the highest and the second highest Bank branche(per 100,000 adults) of Honduras?
Make the answer very short. 0.95. What is the difference between the highest and the second highest Bank branche(per 100,000 adults) in Namibia?
Your answer should be very brief. 0.02. What is the difference between the highest and the second highest Bank branche(per 100,000 adults) of Paraguay?
Your response must be concise. 0.29. What is the difference between the highest and the lowest Bank branche(per 100,000 adults) of High income: nonOECD?
Provide a short and direct response. 2.88. What is the difference between the highest and the lowest Bank branche(per 100,000 adults) of Honduras?
Your answer should be compact. 3.78. What is the difference between the highest and the lowest Bank branche(per 100,000 adults) of Namibia?
Offer a very short reply. 0.21. What is the difference between the highest and the lowest Bank branche(per 100,000 adults) of Paraguay?
Your answer should be compact. 4.38. 